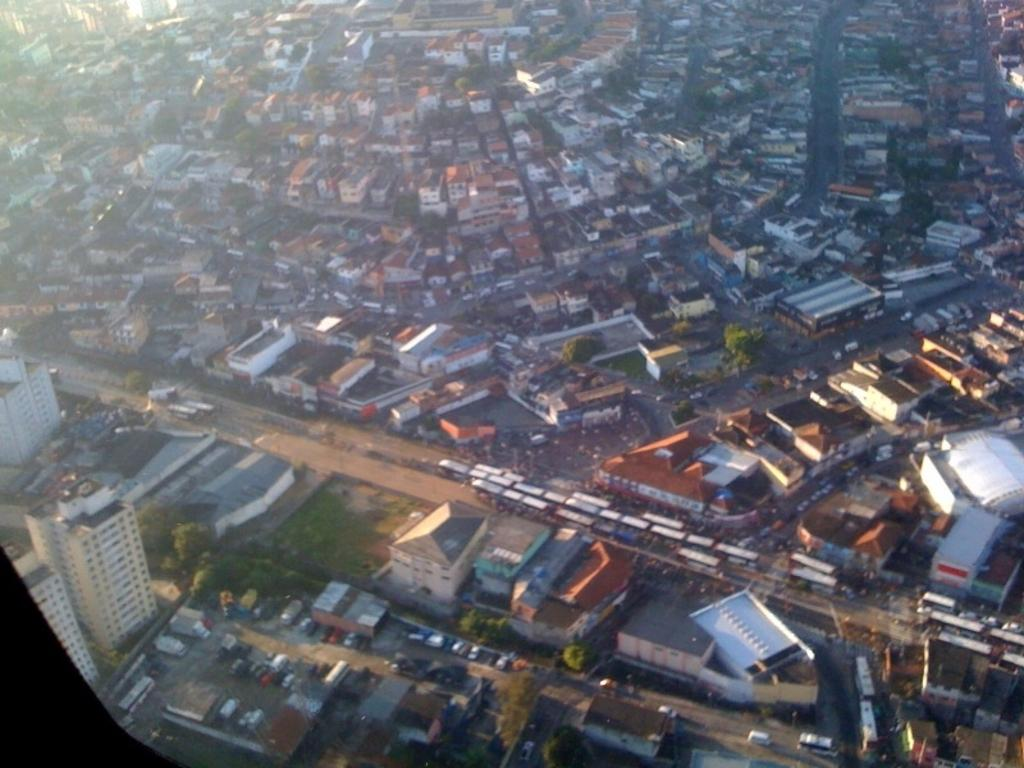What types of structures are visible in the image? There are buildings in the image. What other natural elements can be seen in the image? There are trees in the image. What man-made objects are present in the image? There are vehicles in the image. What color is the brain of the person driving the vehicle in the image? There is no person or brain visible in the image; it only shows buildings, trees, and vehicles. 